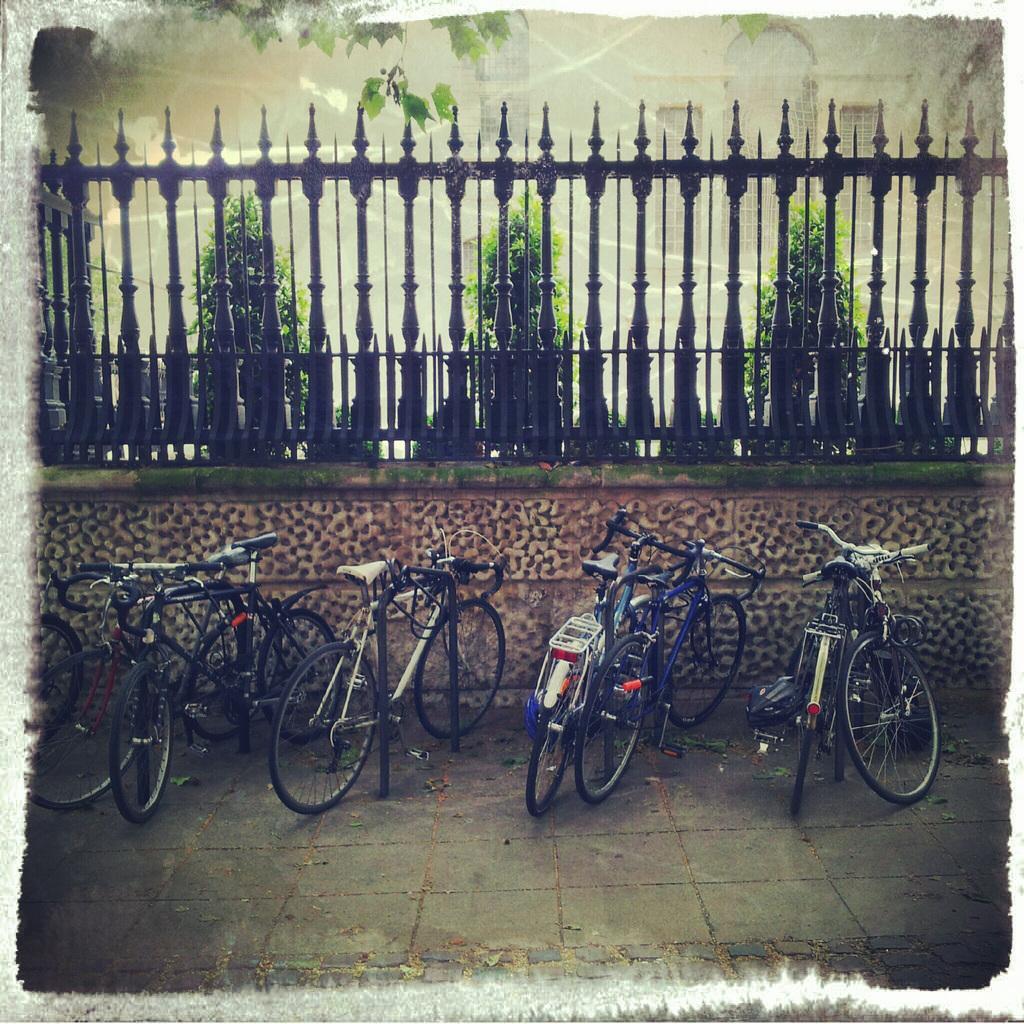Please provide a concise description of this image. In this image I can see the ground, few bicycles on the ground and in the background I can see the wall, the railing, few trees which are green in color and the building which is cream in color. 